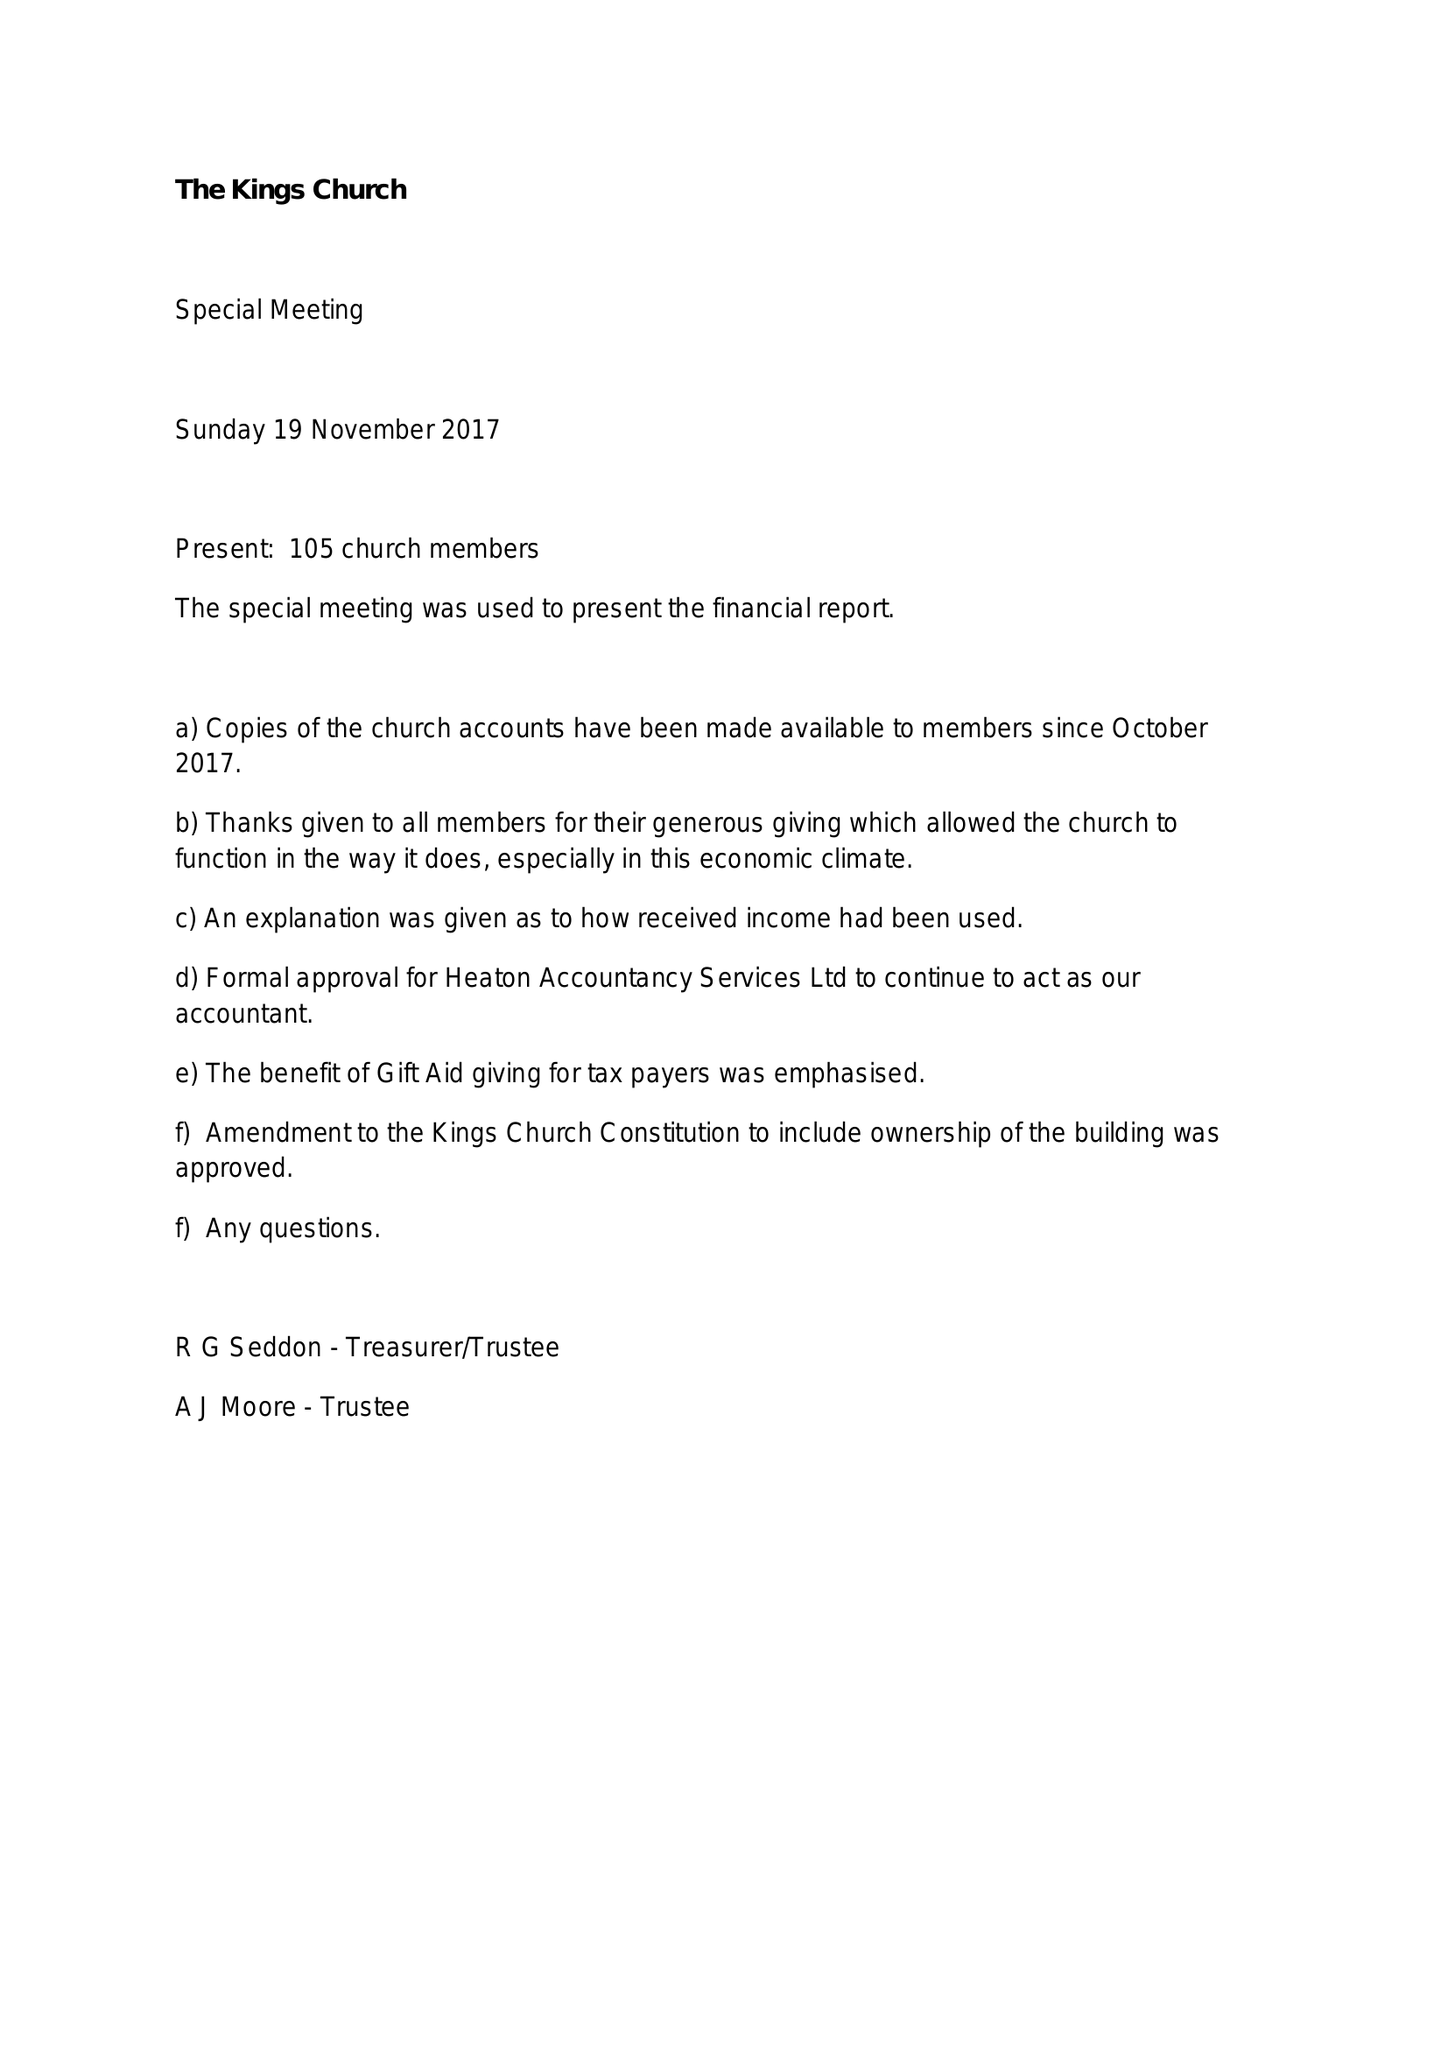What is the value for the charity_name?
Answer the question using a single word or phrase. The King's Church 